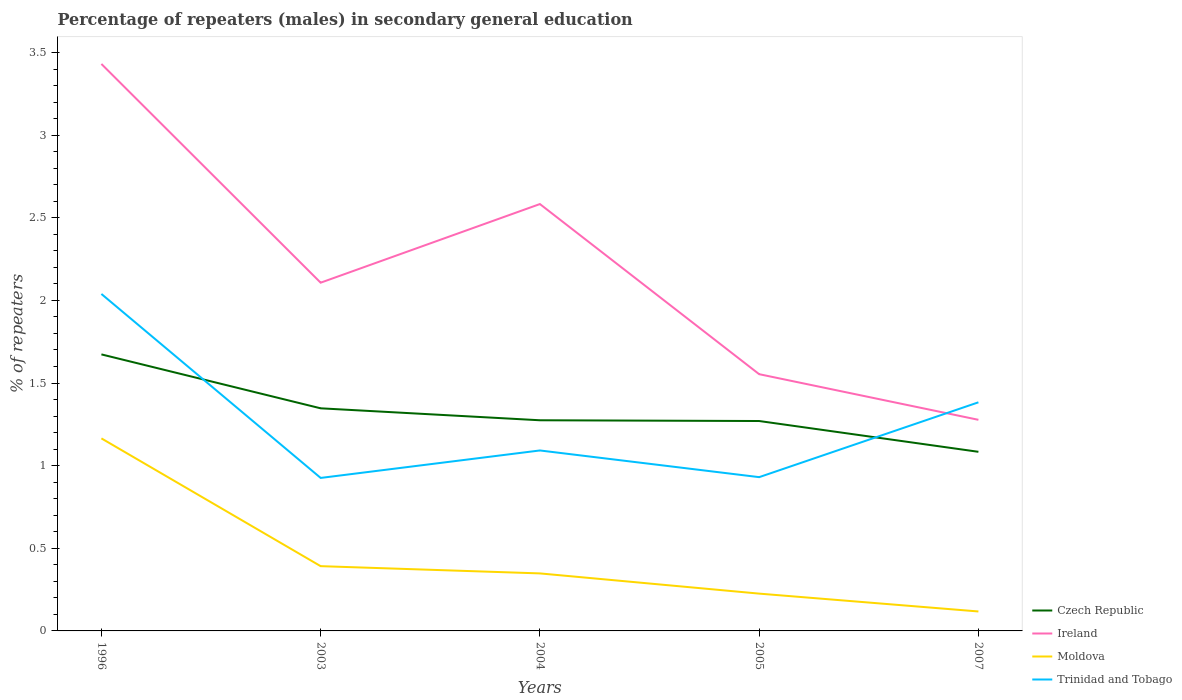Does the line corresponding to Moldova intersect with the line corresponding to Czech Republic?
Your response must be concise. No. Is the number of lines equal to the number of legend labels?
Ensure brevity in your answer.  Yes. Across all years, what is the maximum percentage of male repeaters in Trinidad and Tobago?
Offer a terse response. 0.93. In which year was the percentage of male repeaters in Ireland maximum?
Give a very brief answer. 2007. What is the total percentage of male repeaters in Ireland in the graph?
Provide a succinct answer. 0.85. What is the difference between the highest and the second highest percentage of male repeaters in Czech Republic?
Ensure brevity in your answer.  0.59. What is the difference between the highest and the lowest percentage of male repeaters in Czech Republic?
Make the answer very short. 2. How many lines are there?
Offer a very short reply. 4. How many years are there in the graph?
Provide a succinct answer. 5. Does the graph contain any zero values?
Give a very brief answer. No. Does the graph contain grids?
Make the answer very short. No. Where does the legend appear in the graph?
Your answer should be very brief. Bottom right. What is the title of the graph?
Offer a terse response. Percentage of repeaters (males) in secondary general education. What is the label or title of the X-axis?
Your response must be concise. Years. What is the label or title of the Y-axis?
Offer a terse response. % of repeaters. What is the % of repeaters in Czech Republic in 1996?
Give a very brief answer. 1.67. What is the % of repeaters in Ireland in 1996?
Make the answer very short. 3.43. What is the % of repeaters of Moldova in 1996?
Your answer should be very brief. 1.17. What is the % of repeaters of Trinidad and Tobago in 1996?
Provide a succinct answer. 2.04. What is the % of repeaters of Czech Republic in 2003?
Your response must be concise. 1.35. What is the % of repeaters of Ireland in 2003?
Offer a very short reply. 2.11. What is the % of repeaters of Moldova in 2003?
Offer a terse response. 0.39. What is the % of repeaters in Trinidad and Tobago in 2003?
Keep it short and to the point. 0.93. What is the % of repeaters in Czech Republic in 2004?
Provide a succinct answer. 1.27. What is the % of repeaters of Ireland in 2004?
Offer a terse response. 2.58. What is the % of repeaters in Moldova in 2004?
Keep it short and to the point. 0.35. What is the % of repeaters in Trinidad and Tobago in 2004?
Your response must be concise. 1.09. What is the % of repeaters in Czech Republic in 2005?
Your answer should be very brief. 1.27. What is the % of repeaters of Ireland in 2005?
Your answer should be very brief. 1.55. What is the % of repeaters of Moldova in 2005?
Your answer should be very brief. 0.23. What is the % of repeaters in Trinidad and Tobago in 2005?
Your answer should be compact. 0.93. What is the % of repeaters in Czech Republic in 2007?
Your answer should be compact. 1.08. What is the % of repeaters of Ireland in 2007?
Offer a very short reply. 1.28. What is the % of repeaters of Moldova in 2007?
Ensure brevity in your answer.  0.12. What is the % of repeaters of Trinidad and Tobago in 2007?
Keep it short and to the point. 1.38. Across all years, what is the maximum % of repeaters of Czech Republic?
Offer a terse response. 1.67. Across all years, what is the maximum % of repeaters in Ireland?
Your answer should be very brief. 3.43. Across all years, what is the maximum % of repeaters of Moldova?
Your answer should be very brief. 1.17. Across all years, what is the maximum % of repeaters in Trinidad and Tobago?
Provide a short and direct response. 2.04. Across all years, what is the minimum % of repeaters of Czech Republic?
Give a very brief answer. 1.08. Across all years, what is the minimum % of repeaters in Ireland?
Ensure brevity in your answer.  1.28. Across all years, what is the minimum % of repeaters in Moldova?
Provide a succinct answer. 0.12. Across all years, what is the minimum % of repeaters of Trinidad and Tobago?
Your answer should be very brief. 0.93. What is the total % of repeaters of Czech Republic in the graph?
Keep it short and to the point. 6.65. What is the total % of repeaters of Ireland in the graph?
Make the answer very short. 10.95. What is the total % of repeaters in Moldova in the graph?
Provide a short and direct response. 2.25. What is the total % of repeaters in Trinidad and Tobago in the graph?
Give a very brief answer. 6.37. What is the difference between the % of repeaters of Czech Republic in 1996 and that in 2003?
Give a very brief answer. 0.33. What is the difference between the % of repeaters of Ireland in 1996 and that in 2003?
Your answer should be very brief. 1.32. What is the difference between the % of repeaters in Moldova in 1996 and that in 2003?
Your response must be concise. 0.77. What is the difference between the % of repeaters of Trinidad and Tobago in 1996 and that in 2003?
Give a very brief answer. 1.11. What is the difference between the % of repeaters of Czech Republic in 1996 and that in 2004?
Your response must be concise. 0.4. What is the difference between the % of repeaters in Ireland in 1996 and that in 2004?
Give a very brief answer. 0.85. What is the difference between the % of repeaters of Moldova in 1996 and that in 2004?
Provide a succinct answer. 0.82. What is the difference between the % of repeaters in Trinidad and Tobago in 1996 and that in 2004?
Make the answer very short. 0.95. What is the difference between the % of repeaters in Czech Republic in 1996 and that in 2005?
Offer a terse response. 0.4. What is the difference between the % of repeaters in Ireland in 1996 and that in 2005?
Keep it short and to the point. 1.88. What is the difference between the % of repeaters of Moldova in 1996 and that in 2005?
Your response must be concise. 0.94. What is the difference between the % of repeaters in Trinidad and Tobago in 1996 and that in 2005?
Your response must be concise. 1.11. What is the difference between the % of repeaters in Czech Republic in 1996 and that in 2007?
Make the answer very short. 0.59. What is the difference between the % of repeaters in Ireland in 1996 and that in 2007?
Provide a succinct answer. 2.15. What is the difference between the % of repeaters of Moldova in 1996 and that in 2007?
Ensure brevity in your answer.  1.05. What is the difference between the % of repeaters in Trinidad and Tobago in 1996 and that in 2007?
Provide a succinct answer. 0.66. What is the difference between the % of repeaters of Czech Republic in 2003 and that in 2004?
Provide a short and direct response. 0.07. What is the difference between the % of repeaters in Ireland in 2003 and that in 2004?
Provide a succinct answer. -0.48. What is the difference between the % of repeaters of Moldova in 2003 and that in 2004?
Offer a terse response. 0.04. What is the difference between the % of repeaters of Trinidad and Tobago in 2003 and that in 2004?
Offer a terse response. -0.17. What is the difference between the % of repeaters of Czech Republic in 2003 and that in 2005?
Your answer should be compact. 0.08. What is the difference between the % of repeaters of Ireland in 2003 and that in 2005?
Ensure brevity in your answer.  0.55. What is the difference between the % of repeaters of Moldova in 2003 and that in 2005?
Your answer should be compact. 0.17. What is the difference between the % of repeaters in Trinidad and Tobago in 2003 and that in 2005?
Provide a short and direct response. -0. What is the difference between the % of repeaters in Czech Republic in 2003 and that in 2007?
Keep it short and to the point. 0.26. What is the difference between the % of repeaters of Ireland in 2003 and that in 2007?
Offer a terse response. 0.83. What is the difference between the % of repeaters of Moldova in 2003 and that in 2007?
Ensure brevity in your answer.  0.27. What is the difference between the % of repeaters in Trinidad and Tobago in 2003 and that in 2007?
Make the answer very short. -0.46. What is the difference between the % of repeaters of Czech Republic in 2004 and that in 2005?
Your answer should be compact. 0. What is the difference between the % of repeaters in Ireland in 2004 and that in 2005?
Provide a short and direct response. 1.03. What is the difference between the % of repeaters in Moldova in 2004 and that in 2005?
Ensure brevity in your answer.  0.12. What is the difference between the % of repeaters of Trinidad and Tobago in 2004 and that in 2005?
Your answer should be very brief. 0.16. What is the difference between the % of repeaters of Czech Republic in 2004 and that in 2007?
Provide a succinct answer. 0.19. What is the difference between the % of repeaters in Ireland in 2004 and that in 2007?
Make the answer very short. 1.31. What is the difference between the % of repeaters of Moldova in 2004 and that in 2007?
Offer a terse response. 0.23. What is the difference between the % of repeaters of Trinidad and Tobago in 2004 and that in 2007?
Your answer should be compact. -0.29. What is the difference between the % of repeaters in Czech Republic in 2005 and that in 2007?
Provide a short and direct response. 0.19. What is the difference between the % of repeaters of Ireland in 2005 and that in 2007?
Ensure brevity in your answer.  0.28. What is the difference between the % of repeaters in Moldova in 2005 and that in 2007?
Your answer should be very brief. 0.11. What is the difference between the % of repeaters of Trinidad and Tobago in 2005 and that in 2007?
Provide a short and direct response. -0.45. What is the difference between the % of repeaters of Czech Republic in 1996 and the % of repeaters of Ireland in 2003?
Provide a short and direct response. -0.43. What is the difference between the % of repeaters of Czech Republic in 1996 and the % of repeaters of Moldova in 2003?
Make the answer very short. 1.28. What is the difference between the % of repeaters in Czech Republic in 1996 and the % of repeaters in Trinidad and Tobago in 2003?
Ensure brevity in your answer.  0.75. What is the difference between the % of repeaters of Ireland in 1996 and the % of repeaters of Moldova in 2003?
Make the answer very short. 3.04. What is the difference between the % of repeaters in Ireland in 1996 and the % of repeaters in Trinidad and Tobago in 2003?
Keep it short and to the point. 2.5. What is the difference between the % of repeaters of Moldova in 1996 and the % of repeaters of Trinidad and Tobago in 2003?
Offer a very short reply. 0.24. What is the difference between the % of repeaters of Czech Republic in 1996 and the % of repeaters of Ireland in 2004?
Make the answer very short. -0.91. What is the difference between the % of repeaters of Czech Republic in 1996 and the % of repeaters of Moldova in 2004?
Ensure brevity in your answer.  1.33. What is the difference between the % of repeaters of Czech Republic in 1996 and the % of repeaters of Trinidad and Tobago in 2004?
Offer a terse response. 0.58. What is the difference between the % of repeaters in Ireland in 1996 and the % of repeaters in Moldova in 2004?
Provide a short and direct response. 3.08. What is the difference between the % of repeaters in Ireland in 1996 and the % of repeaters in Trinidad and Tobago in 2004?
Offer a very short reply. 2.34. What is the difference between the % of repeaters in Moldova in 1996 and the % of repeaters in Trinidad and Tobago in 2004?
Keep it short and to the point. 0.07. What is the difference between the % of repeaters in Czech Republic in 1996 and the % of repeaters in Ireland in 2005?
Offer a very short reply. 0.12. What is the difference between the % of repeaters of Czech Republic in 1996 and the % of repeaters of Moldova in 2005?
Give a very brief answer. 1.45. What is the difference between the % of repeaters in Czech Republic in 1996 and the % of repeaters in Trinidad and Tobago in 2005?
Your answer should be compact. 0.74. What is the difference between the % of repeaters in Ireland in 1996 and the % of repeaters in Moldova in 2005?
Your response must be concise. 3.21. What is the difference between the % of repeaters of Ireland in 1996 and the % of repeaters of Trinidad and Tobago in 2005?
Give a very brief answer. 2.5. What is the difference between the % of repeaters in Moldova in 1996 and the % of repeaters in Trinidad and Tobago in 2005?
Your response must be concise. 0.23. What is the difference between the % of repeaters of Czech Republic in 1996 and the % of repeaters of Ireland in 2007?
Your response must be concise. 0.4. What is the difference between the % of repeaters in Czech Republic in 1996 and the % of repeaters in Moldova in 2007?
Your answer should be very brief. 1.56. What is the difference between the % of repeaters of Czech Republic in 1996 and the % of repeaters of Trinidad and Tobago in 2007?
Your response must be concise. 0.29. What is the difference between the % of repeaters in Ireland in 1996 and the % of repeaters in Moldova in 2007?
Ensure brevity in your answer.  3.31. What is the difference between the % of repeaters of Ireland in 1996 and the % of repeaters of Trinidad and Tobago in 2007?
Ensure brevity in your answer.  2.05. What is the difference between the % of repeaters in Moldova in 1996 and the % of repeaters in Trinidad and Tobago in 2007?
Your response must be concise. -0.22. What is the difference between the % of repeaters of Czech Republic in 2003 and the % of repeaters of Ireland in 2004?
Your response must be concise. -1.24. What is the difference between the % of repeaters in Czech Republic in 2003 and the % of repeaters in Trinidad and Tobago in 2004?
Ensure brevity in your answer.  0.26. What is the difference between the % of repeaters of Ireland in 2003 and the % of repeaters of Moldova in 2004?
Provide a succinct answer. 1.76. What is the difference between the % of repeaters of Ireland in 2003 and the % of repeaters of Trinidad and Tobago in 2004?
Make the answer very short. 1.02. What is the difference between the % of repeaters of Moldova in 2003 and the % of repeaters of Trinidad and Tobago in 2004?
Your answer should be very brief. -0.7. What is the difference between the % of repeaters of Czech Republic in 2003 and the % of repeaters of Ireland in 2005?
Provide a succinct answer. -0.21. What is the difference between the % of repeaters of Czech Republic in 2003 and the % of repeaters of Moldova in 2005?
Provide a succinct answer. 1.12. What is the difference between the % of repeaters in Czech Republic in 2003 and the % of repeaters in Trinidad and Tobago in 2005?
Make the answer very short. 0.42. What is the difference between the % of repeaters of Ireland in 2003 and the % of repeaters of Moldova in 2005?
Ensure brevity in your answer.  1.88. What is the difference between the % of repeaters of Ireland in 2003 and the % of repeaters of Trinidad and Tobago in 2005?
Offer a very short reply. 1.18. What is the difference between the % of repeaters in Moldova in 2003 and the % of repeaters in Trinidad and Tobago in 2005?
Make the answer very short. -0.54. What is the difference between the % of repeaters in Czech Republic in 2003 and the % of repeaters in Ireland in 2007?
Offer a terse response. 0.07. What is the difference between the % of repeaters in Czech Republic in 2003 and the % of repeaters in Moldova in 2007?
Keep it short and to the point. 1.23. What is the difference between the % of repeaters in Czech Republic in 2003 and the % of repeaters in Trinidad and Tobago in 2007?
Ensure brevity in your answer.  -0.04. What is the difference between the % of repeaters of Ireland in 2003 and the % of repeaters of Moldova in 2007?
Ensure brevity in your answer.  1.99. What is the difference between the % of repeaters of Ireland in 2003 and the % of repeaters of Trinidad and Tobago in 2007?
Offer a terse response. 0.72. What is the difference between the % of repeaters of Moldova in 2003 and the % of repeaters of Trinidad and Tobago in 2007?
Make the answer very short. -0.99. What is the difference between the % of repeaters of Czech Republic in 2004 and the % of repeaters of Ireland in 2005?
Provide a short and direct response. -0.28. What is the difference between the % of repeaters of Czech Republic in 2004 and the % of repeaters of Moldova in 2005?
Make the answer very short. 1.05. What is the difference between the % of repeaters in Czech Republic in 2004 and the % of repeaters in Trinidad and Tobago in 2005?
Ensure brevity in your answer.  0.34. What is the difference between the % of repeaters of Ireland in 2004 and the % of repeaters of Moldova in 2005?
Provide a succinct answer. 2.36. What is the difference between the % of repeaters in Ireland in 2004 and the % of repeaters in Trinidad and Tobago in 2005?
Make the answer very short. 1.65. What is the difference between the % of repeaters of Moldova in 2004 and the % of repeaters of Trinidad and Tobago in 2005?
Provide a succinct answer. -0.58. What is the difference between the % of repeaters of Czech Republic in 2004 and the % of repeaters of Ireland in 2007?
Provide a succinct answer. -0. What is the difference between the % of repeaters in Czech Republic in 2004 and the % of repeaters in Moldova in 2007?
Provide a short and direct response. 1.16. What is the difference between the % of repeaters of Czech Republic in 2004 and the % of repeaters of Trinidad and Tobago in 2007?
Ensure brevity in your answer.  -0.11. What is the difference between the % of repeaters in Ireland in 2004 and the % of repeaters in Moldova in 2007?
Your answer should be compact. 2.47. What is the difference between the % of repeaters of Ireland in 2004 and the % of repeaters of Trinidad and Tobago in 2007?
Ensure brevity in your answer.  1.2. What is the difference between the % of repeaters of Moldova in 2004 and the % of repeaters of Trinidad and Tobago in 2007?
Provide a short and direct response. -1.04. What is the difference between the % of repeaters in Czech Republic in 2005 and the % of repeaters in Ireland in 2007?
Make the answer very short. -0.01. What is the difference between the % of repeaters of Czech Republic in 2005 and the % of repeaters of Moldova in 2007?
Offer a terse response. 1.15. What is the difference between the % of repeaters of Czech Republic in 2005 and the % of repeaters of Trinidad and Tobago in 2007?
Provide a short and direct response. -0.11. What is the difference between the % of repeaters of Ireland in 2005 and the % of repeaters of Moldova in 2007?
Offer a very short reply. 1.44. What is the difference between the % of repeaters of Ireland in 2005 and the % of repeaters of Trinidad and Tobago in 2007?
Keep it short and to the point. 0.17. What is the difference between the % of repeaters in Moldova in 2005 and the % of repeaters in Trinidad and Tobago in 2007?
Your response must be concise. -1.16. What is the average % of repeaters in Czech Republic per year?
Your answer should be compact. 1.33. What is the average % of repeaters in Ireland per year?
Keep it short and to the point. 2.19. What is the average % of repeaters in Moldova per year?
Your answer should be very brief. 0.45. What is the average % of repeaters of Trinidad and Tobago per year?
Keep it short and to the point. 1.27. In the year 1996, what is the difference between the % of repeaters in Czech Republic and % of repeaters in Ireland?
Make the answer very short. -1.76. In the year 1996, what is the difference between the % of repeaters of Czech Republic and % of repeaters of Moldova?
Your answer should be compact. 0.51. In the year 1996, what is the difference between the % of repeaters in Czech Republic and % of repeaters in Trinidad and Tobago?
Offer a very short reply. -0.37. In the year 1996, what is the difference between the % of repeaters in Ireland and % of repeaters in Moldova?
Give a very brief answer. 2.27. In the year 1996, what is the difference between the % of repeaters in Ireland and % of repeaters in Trinidad and Tobago?
Provide a succinct answer. 1.39. In the year 1996, what is the difference between the % of repeaters in Moldova and % of repeaters in Trinidad and Tobago?
Offer a very short reply. -0.87. In the year 2003, what is the difference between the % of repeaters of Czech Republic and % of repeaters of Ireland?
Give a very brief answer. -0.76. In the year 2003, what is the difference between the % of repeaters of Czech Republic and % of repeaters of Moldova?
Offer a very short reply. 0.96. In the year 2003, what is the difference between the % of repeaters in Czech Republic and % of repeaters in Trinidad and Tobago?
Provide a short and direct response. 0.42. In the year 2003, what is the difference between the % of repeaters in Ireland and % of repeaters in Moldova?
Your answer should be compact. 1.72. In the year 2003, what is the difference between the % of repeaters of Ireland and % of repeaters of Trinidad and Tobago?
Provide a succinct answer. 1.18. In the year 2003, what is the difference between the % of repeaters in Moldova and % of repeaters in Trinidad and Tobago?
Keep it short and to the point. -0.53. In the year 2004, what is the difference between the % of repeaters in Czech Republic and % of repeaters in Ireland?
Ensure brevity in your answer.  -1.31. In the year 2004, what is the difference between the % of repeaters in Czech Republic and % of repeaters in Moldova?
Your answer should be compact. 0.93. In the year 2004, what is the difference between the % of repeaters in Czech Republic and % of repeaters in Trinidad and Tobago?
Offer a very short reply. 0.18. In the year 2004, what is the difference between the % of repeaters in Ireland and % of repeaters in Moldova?
Offer a very short reply. 2.23. In the year 2004, what is the difference between the % of repeaters in Ireland and % of repeaters in Trinidad and Tobago?
Give a very brief answer. 1.49. In the year 2004, what is the difference between the % of repeaters in Moldova and % of repeaters in Trinidad and Tobago?
Offer a terse response. -0.74. In the year 2005, what is the difference between the % of repeaters in Czech Republic and % of repeaters in Ireland?
Give a very brief answer. -0.28. In the year 2005, what is the difference between the % of repeaters in Czech Republic and % of repeaters in Moldova?
Ensure brevity in your answer.  1.04. In the year 2005, what is the difference between the % of repeaters of Czech Republic and % of repeaters of Trinidad and Tobago?
Provide a short and direct response. 0.34. In the year 2005, what is the difference between the % of repeaters in Ireland and % of repeaters in Moldova?
Offer a terse response. 1.33. In the year 2005, what is the difference between the % of repeaters of Ireland and % of repeaters of Trinidad and Tobago?
Offer a very short reply. 0.62. In the year 2005, what is the difference between the % of repeaters of Moldova and % of repeaters of Trinidad and Tobago?
Make the answer very short. -0.7. In the year 2007, what is the difference between the % of repeaters of Czech Republic and % of repeaters of Ireland?
Ensure brevity in your answer.  -0.19. In the year 2007, what is the difference between the % of repeaters in Czech Republic and % of repeaters in Moldova?
Keep it short and to the point. 0.97. In the year 2007, what is the difference between the % of repeaters of Czech Republic and % of repeaters of Trinidad and Tobago?
Offer a very short reply. -0.3. In the year 2007, what is the difference between the % of repeaters of Ireland and % of repeaters of Moldova?
Provide a succinct answer. 1.16. In the year 2007, what is the difference between the % of repeaters of Ireland and % of repeaters of Trinidad and Tobago?
Give a very brief answer. -0.11. In the year 2007, what is the difference between the % of repeaters of Moldova and % of repeaters of Trinidad and Tobago?
Your response must be concise. -1.27. What is the ratio of the % of repeaters of Czech Republic in 1996 to that in 2003?
Your response must be concise. 1.24. What is the ratio of the % of repeaters in Ireland in 1996 to that in 2003?
Your answer should be compact. 1.63. What is the ratio of the % of repeaters in Moldova in 1996 to that in 2003?
Provide a short and direct response. 2.97. What is the ratio of the % of repeaters in Trinidad and Tobago in 1996 to that in 2003?
Your answer should be very brief. 2.2. What is the ratio of the % of repeaters of Czech Republic in 1996 to that in 2004?
Provide a succinct answer. 1.31. What is the ratio of the % of repeaters in Ireland in 1996 to that in 2004?
Ensure brevity in your answer.  1.33. What is the ratio of the % of repeaters of Moldova in 1996 to that in 2004?
Your answer should be compact. 3.35. What is the ratio of the % of repeaters of Trinidad and Tobago in 1996 to that in 2004?
Ensure brevity in your answer.  1.87. What is the ratio of the % of repeaters of Czech Republic in 1996 to that in 2005?
Provide a short and direct response. 1.32. What is the ratio of the % of repeaters in Ireland in 1996 to that in 2005?
Provide a succinct answer. 2.21. What is the ratio of the % of repeaters of Moldova in 1996 to that in 2005?
Give a very brief answer. 5.16. What is the ratio of the % of repeaters in Trinidad and Tobago in 1996 to that in 2005?
Offer a terse response. 2.19. What is the ratio of the % of repeaters of Czech Republic in 1996 to that in 2007?
Give a very brief answer. 1.54. What is the ratio of the % of repeaters in Ireland in 1996 to that in 2007?
Make the answer very short. 2.69. What is the ratio of the % of repeaters of Moldova in 1996 to that in 2007?
Make the answer very short. 9.9. What is the ratio of the % of repeaters in Trinidad and Tobago in 1996 to that in 2007?
Make the answer very short. 1.47. What is the ratio of the % of repeaters of Czech Republic in 2003 to that in 2004?
Keep it short and to the point. 1.06. What is the ratio of the % of repeaters in Ireland in 2003 to that in 2004?
Provide a succinct answer. 0.82. What is the ratio of the % of repeaters in Moldova in 2003 to that in 2004?
Give a very brief answer. 1.13. What is the ratio of the % of repeaters of Trinidad and Tobago in 2003 to that in 2004?
Make the answer very short. 0.85. What is the ratio of the % of repeaters of Czech Republic in 2003 to that in 2005?
Your answer should be very brief. 1.06. What is the ratio of the % of repeaters in Ireland in 2003 to that in 2005?
Provide a short and direct response. 1.36. What is the ratio of the % of repeaters in Moldova in 2003 to that in 2005?
Keep it short and to the point. 1.74. What is the ratio of the % of repeaters in Trinidad and Tobago in 2003 to that in 2005?
Give a very brief answer. 0.99. What is the ratio of the % of repeaters in Czech Republic in 2003 to that in 2007?
Your answer should be very brief. 1.24. What is the ratio of the % of repeaters of Ireland in 2003 to that in 2007?
Your response must be concise. 1.65. What is the ratio of the % of repeaters of Moldova in 2003 to that in 2007?
Make the answer very short. 3.33. What is the ratio of the % of repeaters of Trinidad and Tobago in 2003 to that in 2007?
Provide a succinct answer. 0.67. What is the ratio of the % of repeaters in Czech Republic in 2004 to that in 2005?
Your answer should be compact. 1. What is the ratio of the % of repeaters of Ireland in 2004 to that in 2005?
Offer a very short reply. 1.66. What is the ratio of the % of repeaters of Moldova in 2004 to that in 2005?
Provide a short and direct response. 1.54. What is the ratio of the % of repeaters in Trinidad and Tobago in 2004 to that in 2005?
Provide a succinct answer. 1.17. What is the ratio of the % of repeaters of Czech Republic in 2004 to that in 2007?
Keep it short and to the point. 1.18. What is the ratio of the % of repeaters of Ireland in 2004 to that in 2007?
Offer a terse response. 2.02. What is the ratio of the % of repeaters in Moldova in 2004 to that in 2007?
Offer a very short reply. 2.96. What is the ratio of the % of repeaters of Trinidad and Tobago in 2004 to that in 2007?
Offer a very short reply. 0.79. What is the ratio of the % of repeaters in Czech Republic in 2005 to that in 2007?
Make the answer very short. 1.17. What is the ratio of the % of repeaters in Ireland in 2005 to that in 2007?
Your answer should be compact. 1.22. What is the ratio of the % of repeaters in Moldova in 2005 to that in 2007?
Your answer should be very brief. 1.92. What is the ratio of the % of repeaters of Trinidad and Tobago in 2005 to that in 2007?
Ensure brevity in your answer.  0.67. What is the difference between the highest and the second highest % of repeaters of Czech Republic?
Provide a succinct answer. 0.33. What is the difference between the highest and the second highest % of repeaters of Ireland?
Offer a very short reply. 0.85. What is the difference between the highest and the second highest % of repeaters in Moldova?
Give a very brief answer. 0.77. What is the difference between the highest and the second highest % of repeaters of Trinidad and Tobago?
Provide a succinct answer. 0.66. What is the difference between the highest and the lowest % of repeaters of Czech Republic?
Your answer should be very brief. 0.59. What is the difference between the highest and the lowest % of repeaters of Ireland?
Your answer should be compact. 2.15. What is the difference between the highest and the lowest % of repeaters in Moldova?
Provide a short and direct response. 1.05. What is the difference between the highest and the lowest % of repeaters in Trinidad and Tobago?
Give a very brief answer. 1.11. 